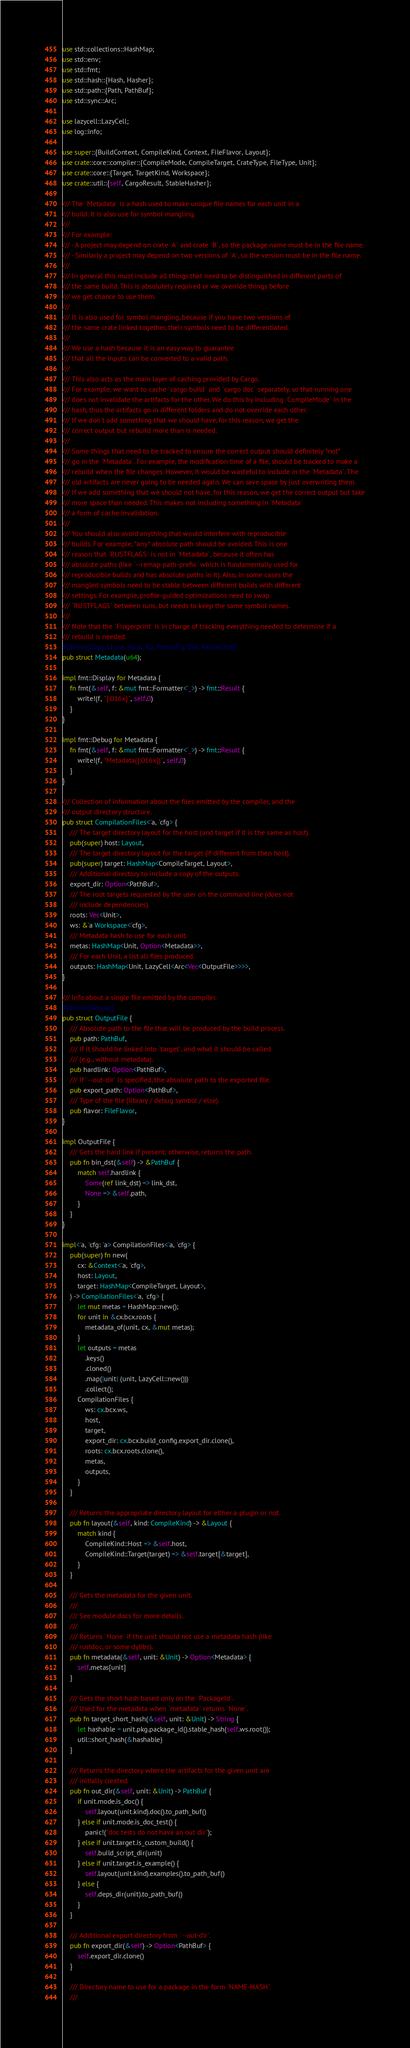Convert code to text. <code><loc_0><loc_0><loc_500><loc_500><_Rust_>use std::collections::HashMap;
use std::env;
use std::fmt;
use std::hash::{Hash, Hasher};
use std::path::{Path, PathBuf};
use std::sync::Arc;

use lazycell::LazyCell;
use log::info;

use super::{BuildContext, CompileKind, Context, FileFlavor, Layout};
use crate::core::compiler::{CompileMode, CompileTarget, CrateType, FileType, Unit};
use crate::core::{Target, TargetKind, Workspace};
use crate::util::{self, CargoResult, StableHasher};

/// The `Metadata` is a hash used to make unique file names for each unit in a
/// build. It is also use for symbol mangling.
///
/// For example:
/// - A project may depend on crate `A` and crate `B`, so the package name must be in the file name.
/// - Similarly a project may depend on two versions of `A`, so the version must be in the file name.
///
/// In general this must include all things that need to be distinguished in different parts of
/// the same build. This is absolutely required or we override things before
/// we get chance to use them.
///
/// It is also used for symbol mangling, because if you have two versions of
/// the same crate linked together, their symbols need to be differentiated.
///
/// We use a hash because it is an easy way to guarantee
/// that all the inputs can be converted to a valid path.
///
/// This also acts as the main layer of caching provided by Cargo.
/// For example, we want to cache `cargo build` and `cargo doc` separately, so that running one
/// does not invalidate the artifacts for the other. We do this by including `CompileMode` in the
/// hash, thus the artifacts go in different folders and do not override each other.
/// If we don't add something that we should have, for this reason, we get the
/// correct output but rebuild more than is needed.
///
/// Some things that need to be tracked to ensure the correct output should definitely *not*
/// go in the `Metadata`. For example, the modification time of a file, should be tracked to make a
/// rebuild when the file changes. However, it would be wasteful to include in the `Metadata`. The
/// old artifacts are never going to be needed again. We can save space by just overwriting them.
/// If we add something that we should not have, for this reason, we get the correct output but take
/// more space than needed. This makes not including something in `Metadata`
/// a form of cache invalidation.
///
/// You should also avoid anything that would interfere with reproducible
/// builds. For example, *any* absolute path should be avoided. This is one
/// reason that `RUSTFLAGS` is not in `Metadata`, because it often has
/// absolute paths (like `--remap-path-prefix` which is fundamentally used for
/// reproducible builds and has absolute paths in it). Also, in some cases the
/// mangled symbols need to be stable between different builds with different
/// settings. For example, profile-guided optimizations need to swap
/// `RUSTFLAGS` between runs, but needs to keep the same symbol names.
///
/// Note that the `Fingerprint` is in charge of tracking everything needed to determine if a
/// rebuild is needed.
#[derive(Copy, Clone, Hash, Eq, PartialEq, Ord, PartialOrd)]
pub struct Metadata(u64);

impl fmt::Display for Metadata {
    fn fmt(&self, f: &mut fmt::Formatter<'_>) -> fmt::Result {
        write!(f, "{:016x}", self.0)
    }
}

impl fmt::Debug for Metadata {
    fn fmt(&self, f: &mut fmt::Formatter<'_>) -> fmt::Result {
        write!(f, "Metadata({:016x})", self.0)
    }
}

/// Collection of information about the files emitted by the compiler, and the
/// output directory structure.
pub struct CompilationFiles<'a, 'cfg> {
    /// The target directory layout for the host (and target if it is the same as host).
    pub(super) host: Layout,
    /// The target directory layout for the target (if different from then host).
    pub(super) target: HashMap<CompileTarget, Layout>,
    /// Additional directory to include a copy of the outputs.
    export_dir: Option<PathBuf>,
    /// The root targets requested by the user on the command line (does not
    /// include dependencies).
    roots: Vec<Unit>,
    ws: &'a Workspace<'cfg>,
    /// Metadata hash to use for each unit.
    metas: HashMap<Unit, Option<Metadata>>,
    /// For each Unit, a list all files produced.
    outputs: HashMap<Unit, LazyCell<Arc<Vec<OutputFile>>>>,
}

/// Info about a single file emitted by the compiler.
#[derive(Debug)]
pub struct OutputFile {
    /// Absolute path to the file that will be produced by the build process.
    pub path: PathBuf,
    /// If it should be linked into `target`, and what it should be called
    /// (e.g., without metadata).
    pub hardlink: Option<PathBuf>,
    /// If `--out-dir` is specified, the absolute path to the exported file.
    pub export_path: Option<PathBuf>,
    /// Type of the file (library / debug symbol / else).
    pub flavor: FileFlavor,
}

impl OutputFile {
    /// Gets the hard link if present; otherwise, returns the path.
    pub fn bin_dst(&self) -> &PathBuf {
        match self.hardlink {
            Some(ref link_dst) => link_dst,
            None => &self.path,
        }
    }
}

impl<'a, 'cfg: 'a> CompilationFiles<'a, 'cfg> {
    pub(super) fn new(
        cx: &Context<'a, 'cfg>,
        host: Layout,
        target: HashMap<CompileTarget, Layout>,
    ) -> CompilationFiles<'a, 'cfg> {
        let mut metas = HashMap::new();
        for unit in &cx.bcx.roots {
            metadata_of(unit, cx, &mut metas);
        }
        let outputs = metas
            .keys()
            .cloned()
            .map(|unit| (unit, LazyCell::new()))
            .collect();
        CompilationFiles {
            ws: cx.bcx.ws,
            host,
            target,
            export_dir: cx.bcx.build_config.export_dir.clone(),
            roots: cx.bcx.roots.clone(),
            metas,
            outputs,
        }
    }

    /// Returns the appropriate directory layout for either a plugin or not.
    pub fn layout(&self, kind: CompileKind) -> &Layout {
        match kind {
            CompileKind::Host => &self.host,
            CompileKind::Target(target) => &self.target[&target],
        }
    }

    /// Gets the metadata for the given unit.
    ///
    /// See module docs for more details.
    ///
    /// Returns `None` if the unit should not use a metadata hash (like
    /// rustdoc, or some dylibs).
    pub fn metadata(&self, unit: &Unit) -> Option<Metadata> {
        self.metas[unit]
    }

    /// Gets the short hash based only on the `PackageId`.
    /// Used for the metadata when `metadata` returns `None`.
    pub fn target_short_hash(&self, unit: &Unit) -> String {
        let hashable = unit.pkg.package_id().stable_hash(self.ws.root());
        util::short_hash(&hashable)
    }

    /// Returns the directory where the artifacts for the given unit are
    /// initially created.
    pub fn out_dir(&self, unit: &Unit) -> PathBuf {
        if unit.mode.is_doc() {
            self.layout(unit.kind).doc().to_path_buf()
        } else if unit.mode.is_doc_test() {
            panic!("doc tests do not have an out dir");
        } else if unit.target.is_custom_build() {
            self.build_script_dir(unit)
        } else if unit.target.is_example() {
            self.layout(unit.kind).examples().to_path_buf()
        } else {
            self.deps_dir(unit).to_path_buf()
        }
    }

    /// Additional export directory from `--out-dir`.
    pub fn export_dir(&self) -> Option<PathBuf> {
        self.export_dir.clone()
    }

    /// Directory name to use for a package in the form `NAME-HASH`.
    ///</code> 